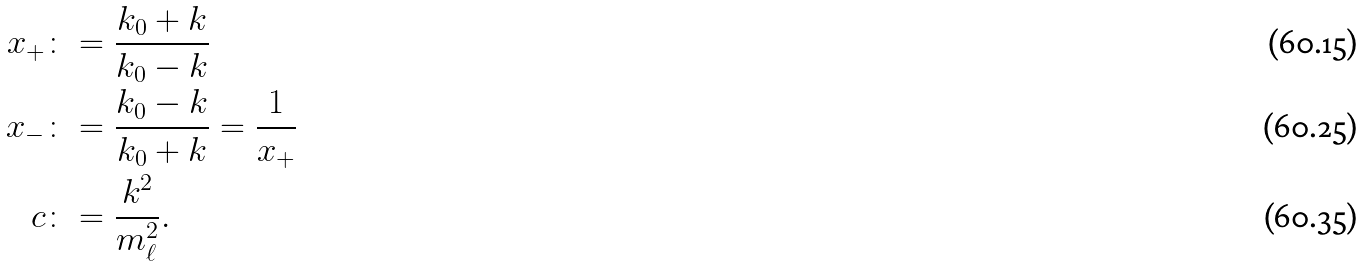Convert formula to latex. <formula><loc_0><loc_0><loc_500><loc_500>x _ { + } & \colon = \frac { k _ { 0 } + k } { k _ { 0 } - k } \\ x _ { - } & \colon = \frac { k _ { 0 } - k } { k _ { 0 } + k } = \frac { 1 } { x _ { + } } \\ c & \colon = \frac { k ^ { 2 } } { m _ { \ell } ^ { 2 } } .</formula> 